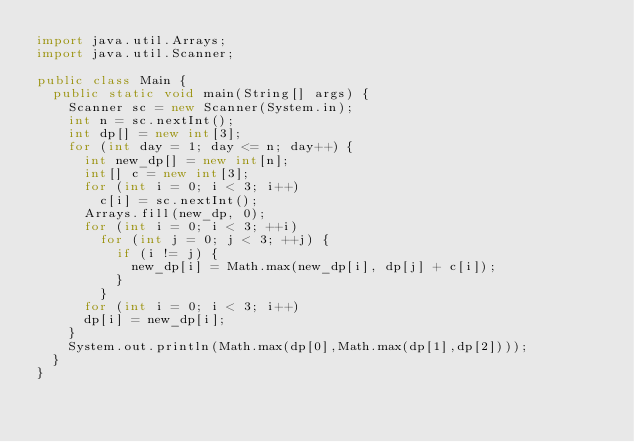Convert code to text. <code><loc_0><loc_0><loc_500><loc_500><_Java_>import java.util.Arrays;
import java.util.Scanner;

public class Main {
  public static void main(String[] args) {
    Scanner sc = new Scanner(System.in);
    int n = sc.nextInt();
    int dp[] = new int[3];
    for (int day = 1; day <= n; day++) {
      int new_dp[] = new int[n];
      int[] c = new int[3];
      for (int i = 0; i < 3; i++)
        c[i] = sc.nextInt();
      Arrays.fill(new_dp, 0);
      for (int i = 0; i < 3; ++i)
        for (int j = 0; j < 3; ++j) {
          if (i != j) {
            new_dp[i] = Math.max(new_dp[i], dp[j] + c[i]);
          }
        }
      for (int i = 0; i < 3; i++)
      dp[i] = new_dp[i];
    }
    System.out.println(Math.max(dp[0],Math.max(dp[1],dp[2])));
  }
}</code> 